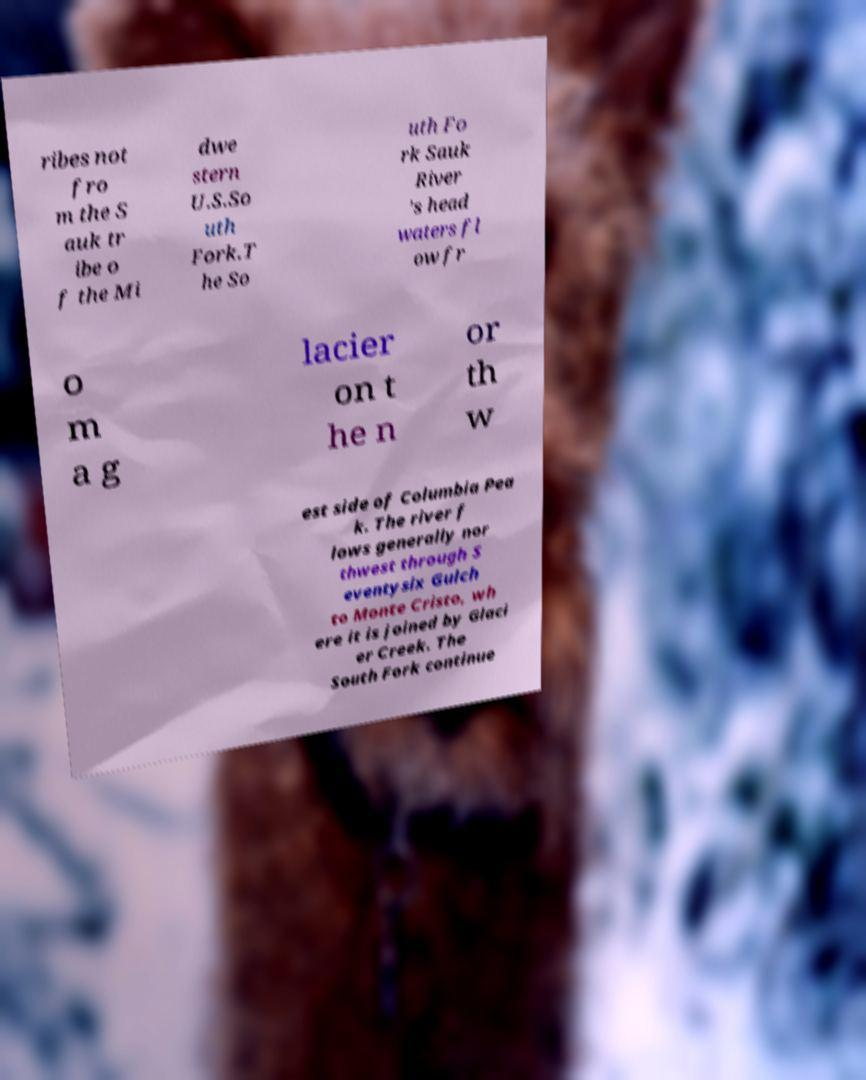Please identify and transcribe the text found in this image. ribes not fro m the S auk tr ibe o f the Mi dwe stern U.S.So uth Fork.T he So uth Fo rk Sauk River 's head waters fl ow fr o m a g lacier on t he n or th w est side of Columbia Pea k. The river f lows generally nor thwest through S eventysix Gulch to Monte Cristo, wh ere it is joined by Glaci er Creek. The South Fork continue 